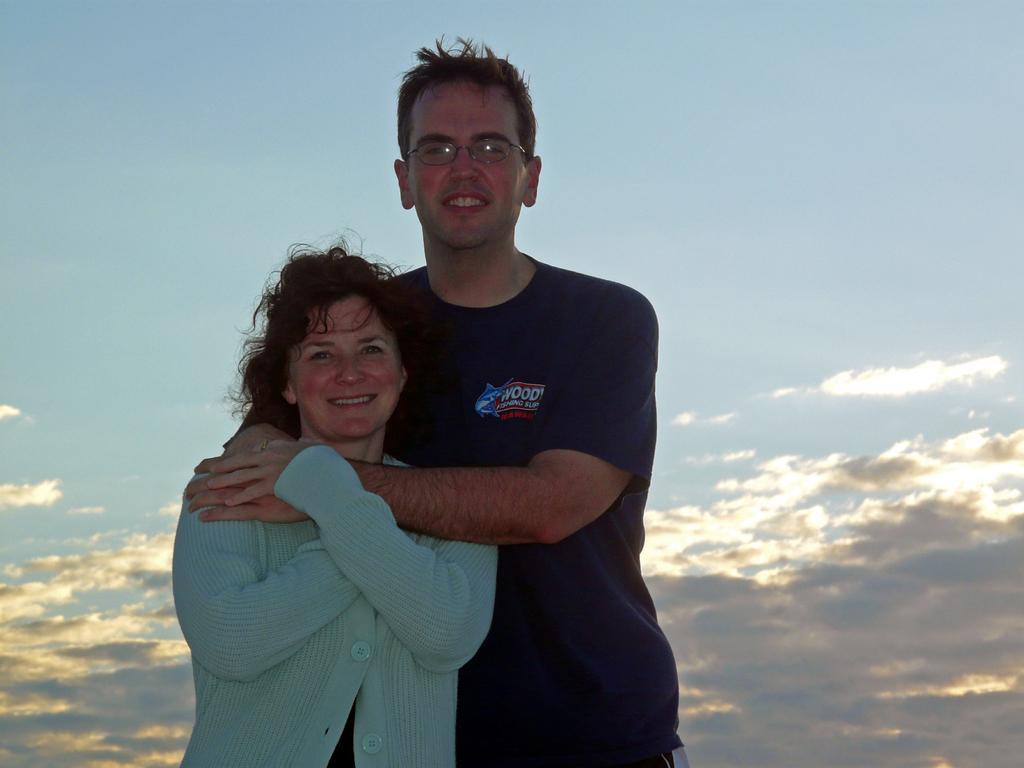How would you summarize this image in a sentence or two? In this image there is a man and a woman standing. The man is holding the woman. Behind them there is the sky. 